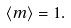Convert formula to latex. <formula><loc_0><loc_0><loc_500><loc_500>\langle m \rangle = 1 .</formula> 